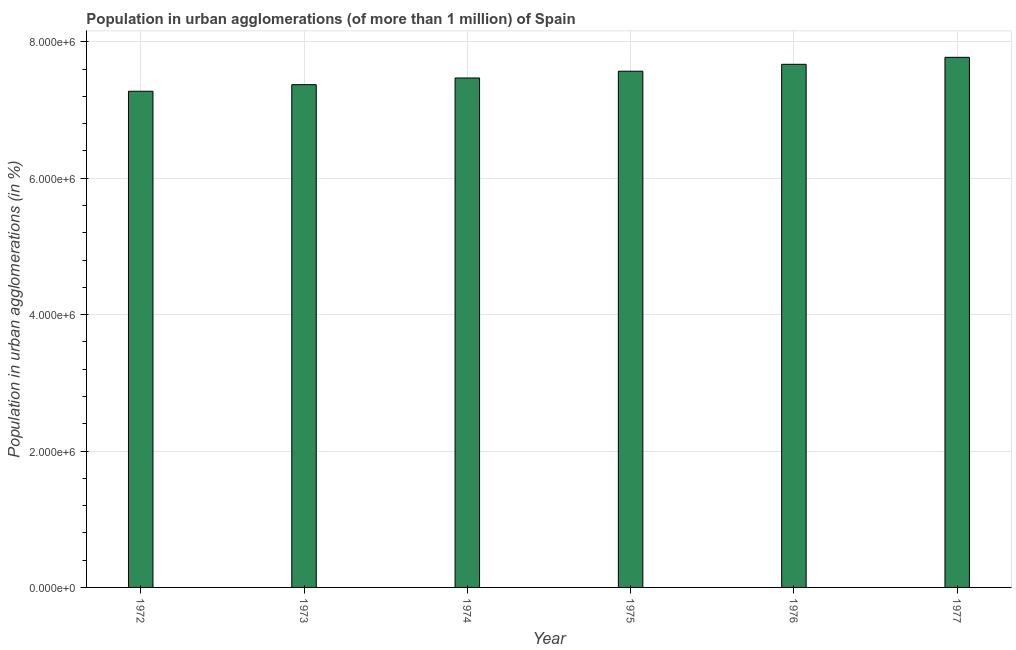What is the title of the graph?
Provide a succinct answer. Population in urban agglomerations (of more than 1 million) of Spain. What is the label or title of the X-axis?
Make the answer very short. Year. What is the label or title of the Y-axis?
Your answer should be very brief. Population in urban agglomerations (in %). What is the population in urban agglomerations in 1972?
Keep it short and to the point. 7.28e+06. Across all years, what is the maximum population in urban agglomerations?
Give a very brief answer. 7.77e+06. Across all years, what is the minimum population in urban agglomerations?
Provide a short and direct response. 7.28e+06. In which year was the population in urban agglomerations maximum?
Keep it short and to the point. 1977. In which year was the population in urban agglomerations minimum?
Your answer should be very brief. 1972. What is the sum of the population in urban agglomerations?
Give a very brief answer. 4.51e+07. What is the difference between the population in urban agglomerations in 1972 and 1973?
Keep it short and to the point. -9.64e+04. What is the average population in urban agglomerations per year?
Your answer should be compact. 7.52e+06. What is the median population in urban agglomerations?
Give a very brief answer. 7.52e+06. In how many years, is the population in urban agglomerations greater than 5200000 %?
Provide a succinct answer. 6. What is the ratio of the population in urban agglomerations in 1973 to that in 1977?
Make the answer very short. 0.95. Is the population in urban agglomerations in 1972 less than that in 1976?
Offer a very short reply. Yes. Is the difference between the population in urban agglomerations in 1972 and 1976 greater than the difference between any two years?
Your answer should be compact. No. What is the difference between the highest and the second highest population in urban agglomerations?
Ensure brevity in your answer.  1.02e+05. What is the difference between the highest and the lowest population in urban agglomerations?
Provide a succinct answer. 4.97e+05. In how many years, is the population in urban agglomerations greater than the average population in urban agglomerations taken over all years?
Your answer should be very brief. 3. How many bars are there?
Your response must be concise. 6. What is the difference between two consecutive major ticks on the Y-axis?
Ensure brevity in your answer.  2.00e+06. Are the values on the major ticks of Y-axis written in scientific E-notation?
Offer a very short reply. Yes. What is the Population in urban agglomerations (in %) in 1972?
Provide a short and direct response. 7.28e+06. What is the Population in urban agglomerations (in %) of 1973?
Provide a succinct answer. 7.37e+06. What is the Population in urban agglomerations (in %) in 1974?
Make the answer very short. 7.47e+06. What is the Population in urban agglomerations (in %) in 1975?
Provide a short and direct response. 7.57e+06. What is the Population in urban agglomerations (in %) in 1976?
Offer a terse response. 7.67e+06. What is the Population in urban agglomerations (in %) in 1977?
Make the answer very short. 7.77e+06. What is the difference between the Population in urban agglomerations (in %) in 1972 and 1973?
Offer a terse response. -9.64e+04. What is the difference between the Population in urban agglomerations (in %) in 1972 and 1974?
Offer a very short reply. -1.94e+05. What is the difference between the Population in urban agglomerations (in %) in 1972 and 1975?
Provide a succinct answer. -2.94e+05. What is the difference between the Population in urban agglomerations (in %) in 1972 and 1976?
Offer a very short reply. -3.95e+05. What is the difference between the Population in urban agglomerations (in %) in 1972 and 1977?
Your response must be concise. -4.97e+05. What is the difference between the Population in urban agglomerations (in %) in 1973 and 1974?
Provide a succinct answer. -9.80e+04. What is the difference between the Population in urban agglomerations (in %) in 1973 and 1975?
Provide a short and direct response. -1.98e+05. What is the difference between the Population in urban agglomerations (in %) in 1973 and 1976?
Your answer should be very brief. -2.99e+05. What is the difference between the Population in urban agglomerations (in %) in 1973 and 1977?
Give a very brief answer. -4.01e+05. What is the difference between the Population in urban agglomerations (in %) in 1974 and 1975?
Keep it short and to the point. -9.95e+04. What is the difference between the Population in urban agglomerations (in %) in 1974 and 1976?
Provide a succinct answer. -2.01e+05. What is the difference between the Population in urban agglomerations (in %) in 1974 and 1977?
Your answer should be compact. -3.03e+05. What is the difference between the Population in urban agglomerations (in %) in 1975 and 1976?
Ensure brevity in your answer.  -1.01e+05. What is the difference between the Population in urban agglomerations (in %) in 1975 and 1977?
Offer a very short reply. -2.04e+05. What is the difference between the Population in urban agglomerations (in %) in 1976 and 1977?
Provide a short and direct response. -1.02e+05. What is the ratio of the Population in urban agglomerations (in %) in 1972 to that in 1976?
Provide a short and direct response. 0.95. What is the ratio of the Population in urban agglomerations (in %) in 1972 to that in 1977?
Give a very brief answer. 0.94. What is the ratio of the Population in urban agglomerations (in %) in 1973 to that in 1974?
Ensure brevity in your answer.  0.99. What is the ratio of the Population in urban agglomerations (in %) in 1973 to that in 1975?
Make the answer very short. 0.97. What is the ratio of the Population in urban agglomerations (in %) in 1973 to that in 1976?
Your response must be concise. 0.96. What is the ratio of the Population in urban agglomerations (in %) in 1973 to that in 1977?
Give a very brief answer. 0.95. What is the ratio of the Population in urban agglomerations (in %) in 1974 to that in 1975?
Ensure brevity in your answer.  0.99. What is the ratio of the Population in urban agglomerations (in %) in 1974 to that in 1976?
Offer a very short reply. 0.97. What is the ratio of the Population in urban agglomerations (in %) in 1975 to that in 1976?
Offer a terse response. 0.99. What is the ratio of the Population in urban agglomerations (in %) in 1975 to that in 1977?
Your answer should be very brief. 0.97. 